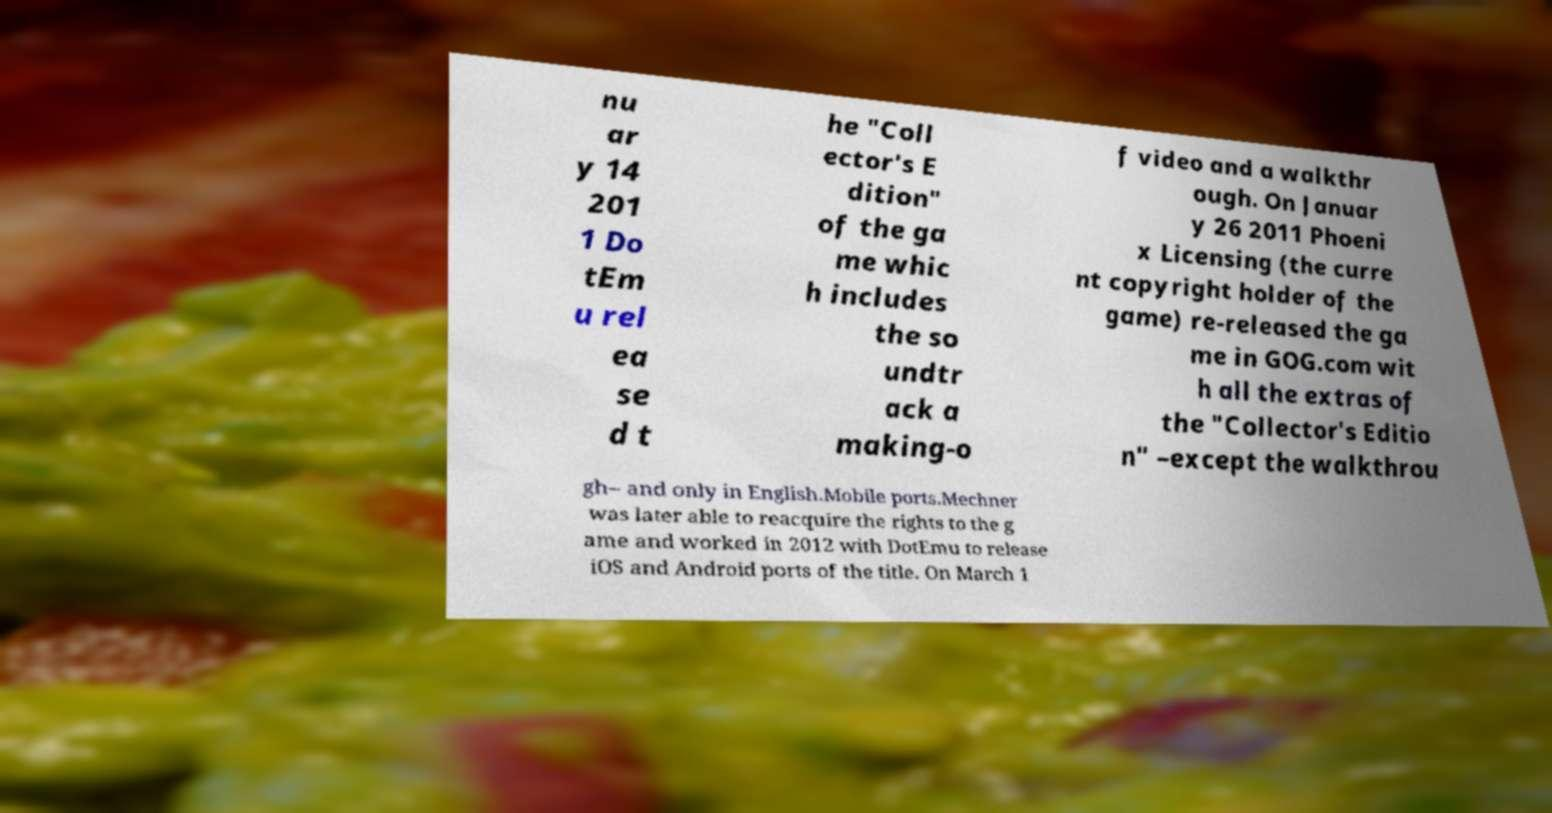Could you extract and type out the text from this image? nu ar y 14 201 1 Do tEm u rel ea se d t he "Coll ector's E dition" of the ga me whic h includes the so undtr ack a making-o f video and a walkthr ough. On Januar y 26 2011 Phoeni x Licensing (the curre nt copyright holder of the game) re-released the ga me in GOG.com wit h all the extras of the "Collector's Editio n" –except the walkthrou gh– and only in English.Mobile ports.Mechner was later able to reacquire the rights to the g ame and worked in 2012 with DotEmu to release iOS and Android ports of the title. On March 1 